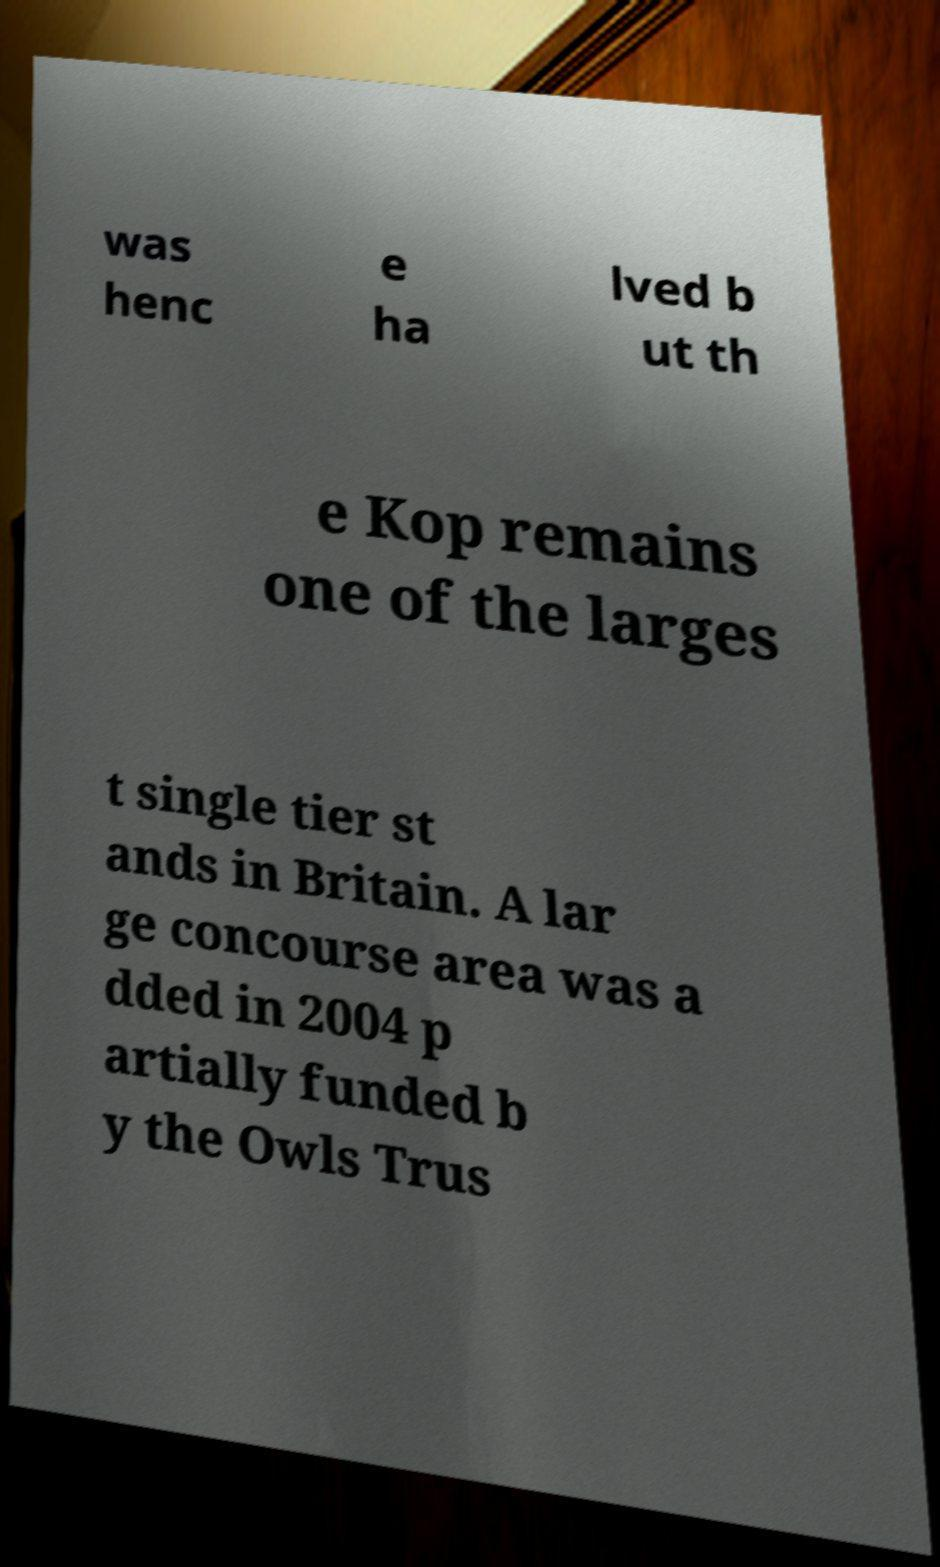For documentation purposes, I need the text within this image transcribed. Could you provide that? was henc e ha lved b ut th e Kop remains one of the larges t single tier st ands in Britain. A lar ge concourse area was a dded in 2004 p artially funded b y the Owls Trus 